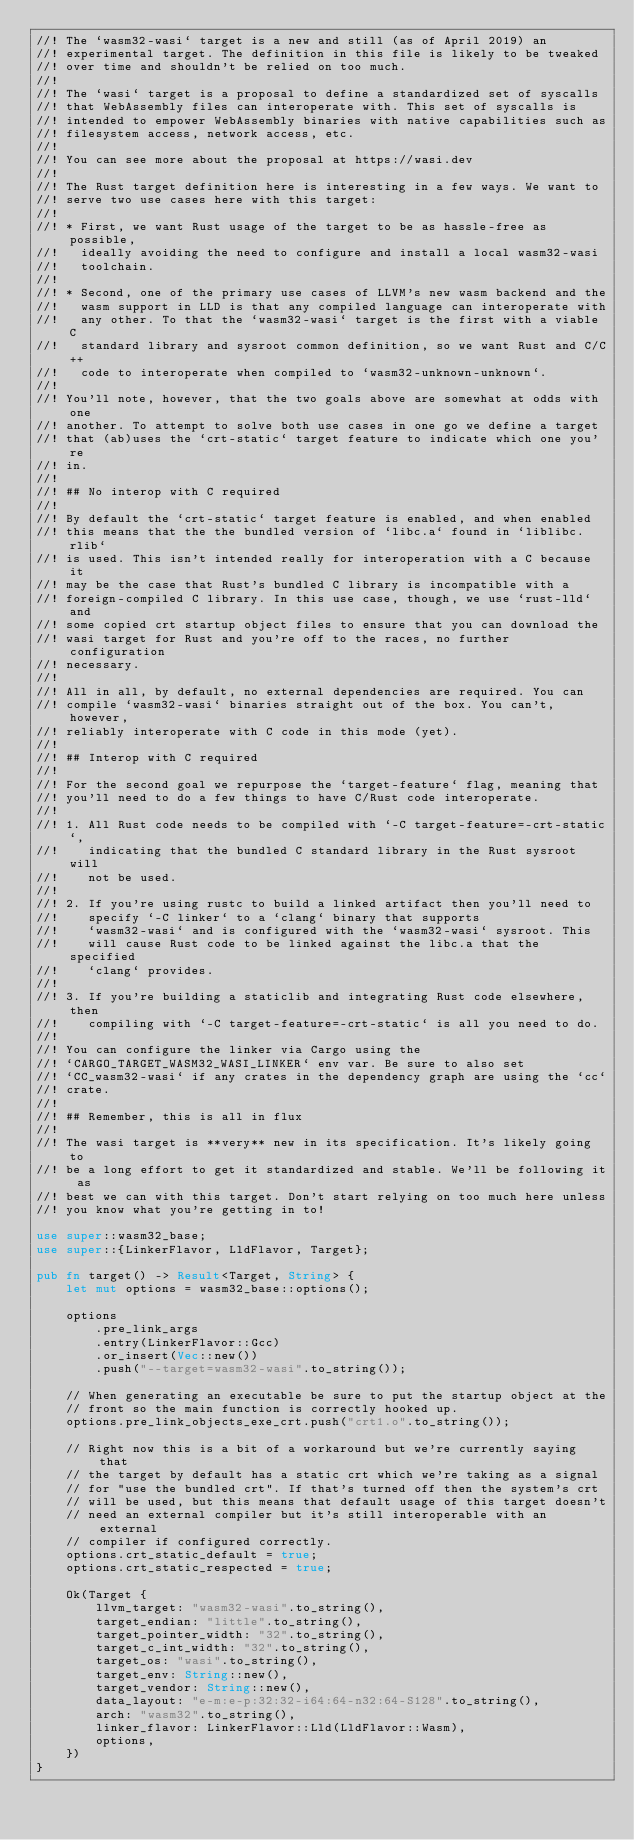Convert code to text. <code><loc_0><loc_0><loc_500><loc_500><_Rust_>//! The `wasm32-wasi` target is a new and still (as of April 2019) an
//! experimental target. The definition in this file is likely to be tweaked
//! over time and shouldn't be relied on too much.
//!
//! The `wasi` target is a proposal to define a standardized set of syscalls
//! that WebAssembly files can interoperate with. This set of syscalls is
//! intended to empower WebAssembly binaries with native capabilities such as
//! filesystem access, network access, etc.
//!
//! You can see more about the proposal at https://wasi.dev
//!
//! The Rust target definition here is interesting in a few ways. We want to
//! serve two use cases here with this target:
//!
//! * First, we want Rust usage of the target to be as hassle-free as possible,
//!   ideally avoiding the need to configure and install a local wasm32-wasi
//!   toolchain.
//!
//! * Second, one of the primary use cases of LLVM's new wasm backend and the
//!   wasm support in LLD is that any compiled language can interoperate with
//!   any other. To that the `wasm32-wasi` target is the first with a viable C
//!   standard library and sysroot common definition, so we want Rust and C/C++
//!   code to interoperate when compiled to `wasm32-unknown-unknown`.
//!
//! You'll note, however, that the two goals above are somewhat at odds with one
//! another. To attempt to solve both use cases in one go we define a target
//! that (ab)uses the `crt-static` target feature to indicate which one you're
//! in.
//!
//! ## No interop with C required
//!
//! By default the `crt-static` target feature is enabled, and when enabled
//! this means that the the bundled version of `libc.a` found in `liblibc.rlib`
//! is used. This isn't intended really for interoperation with a C because it
//! may be the case that Rust's bundled C library is incompatible with a
//! foreign-compiled C library. In this use case, though, we use `rust-lld` and
//! some copied crt startup object files to ensure that you can download the
//! wasi target for Rust and you're off to the races, no further configuration
//! necessary.
//!
//! All in all, by default, no external dependencies are required. You can
//! compile `wasm32-wasi` binaries straight out of the box. You can't, however,
//! reliably interoperate with C code in this mode (yet).
//!
//! ## Interop with C required
//!
//! For the second goal we repurpose the `target-feature` flag, meaning that
//! you'll need to do a few things to have C/Rust code interoperate.
//!
//! 1. All Rust code needs to be compiled with `-C target-feature=-crt-static`,
//!    indicating that the bundled C standard library in the Rust sysroot will
//!    not be used.
//!
//! 2. If you're using rustc to build a linked artifact then you'll need to
//!    specify `-C linker` to a `clang` binary that supports
//!    `wasm32-wasi` and is configured with the `wasm32-wasi` sysroot. This
//!    will cause Rust code to be linked against the libc.a that the specified
//!    `clang` provides.
//!
//! 3. If you're building a staticlib and integrating Rust code elsewhere, then
//!    compiling with `-C target-feature=-crt-static` is all you need to do.
//!
//! You can configure the linker via Cargo using the
//! `CARGO_TARGET_WASM32_WASI_LINKER` env var. Be sure to also set
//! `CC_wasm32-wasi` if any crates in the dependency graph are using the `cc`
//! crate.
//!
//! ## Remember, this is all in flux
//!
//! The wasi target is **very** new in its specification. It's likely going to
//! be a long effort to get it standardized and stable. We'll be following it as
//! best we can with this target. Don't start relying on too much here unless
//! you know what you're getting in to!

use super::wasm32_base;
use super::{LinkerFlavor, LldFlavor, Target};

pub fn target() -> Result<Target, String> {
    let mut options = wasm32_base::options();

    options
        .pre_link_args
        .entry(LinkerFlavor::Gcc)
        .or_insert(Vec::new())
        .push("--target=wasm32-wasi".to_string());

    // When generating an executable be sure to put the startup object at the
    // front so the main function is correctly hooked up.
    options.pre_link_objects_exe_crt.push("crt1.o".to_string());

    // Right now this is a bit of a workaround but we're currently saying that
    // the target by default has a static crt which we're taking as a signal
    // for "use the bundled crt". If that's turned off then the system's crt
    // will be used, but this means that default usage of this target doesn't
    // need an external compiler but it's still interoperable with an external
    // compiler if configured correctly.
    options.crt_static_default = true;
    options.crt_static_respected = true;

    Ok(Target {
        llvm_target: "wasm32-wasi".to_string(),
        target_endian: "little".to_string(),
        target_pointer_width: "32".to_string(),
        target_c_int_width: "32".to_string(),
        target_os: "wasi".to_string(),
        target_env: String::new(),
        target_vendor: String::new(),
        data_layout: "e-m:e-p:32:32-i64:64-n32:64-S128".to_string(),
        arch: "wasm32".to_string(),
        linker_flavor: LinkerFlavor::Lld(LldFlavor::Wasm),
        options,
    })
}
</code> 